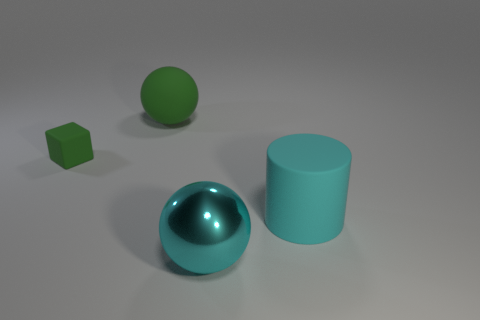Are there any other things that have the same shape as the tiny green thing?
Provide a succinct answer. No. What material is the object that is the same color as the large matte cylinder?
Your answer should be compact. Metal. Does the metal object have the same color as the large cylinder?
Provide a short and direct response. Yes. What is the sphere that is in front of the small rubber cube made of?
Offer a very short reply. Metal. There is another sphere that is the same size as the shiny sphere; what is it made of?
Your response must be concise. Rubber. What is the big cyan object that is on the left side of the cyan object that is behind the large metal ball that is right of the large green rubber ball made of?
Offer a terse response. Metal. Do the object that is left of the green ball and the large green rubber sphere have the same size?
Keep it short and to the point. No. Are there more small red metallic cylinders than big shiny things?
Give a very brief answer. No. How many large objects are either balls or purple rubber spheres?
Offer a very short reply. 2. How many other tiny brown cubes have the same material as the small cube?
Ensure brevity in your answer.  0. 